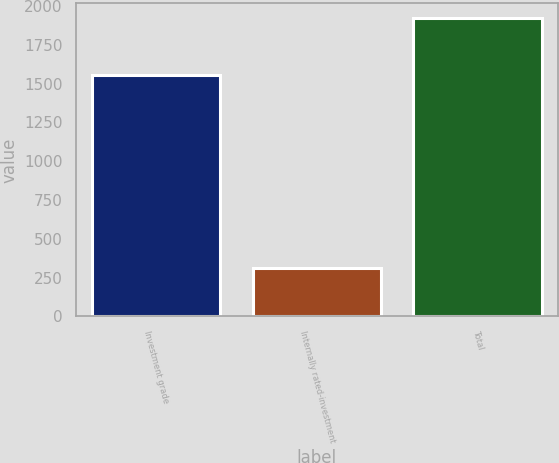Convert chart. <chart><loc_0><loc_0><loc_500><loc_500><bar_chart><fcel>Investment grade<fcel>Internally rated-investment<fcel>Total<nl><fcel>1553<fcel>312<fcel>1921<nl></chart> 